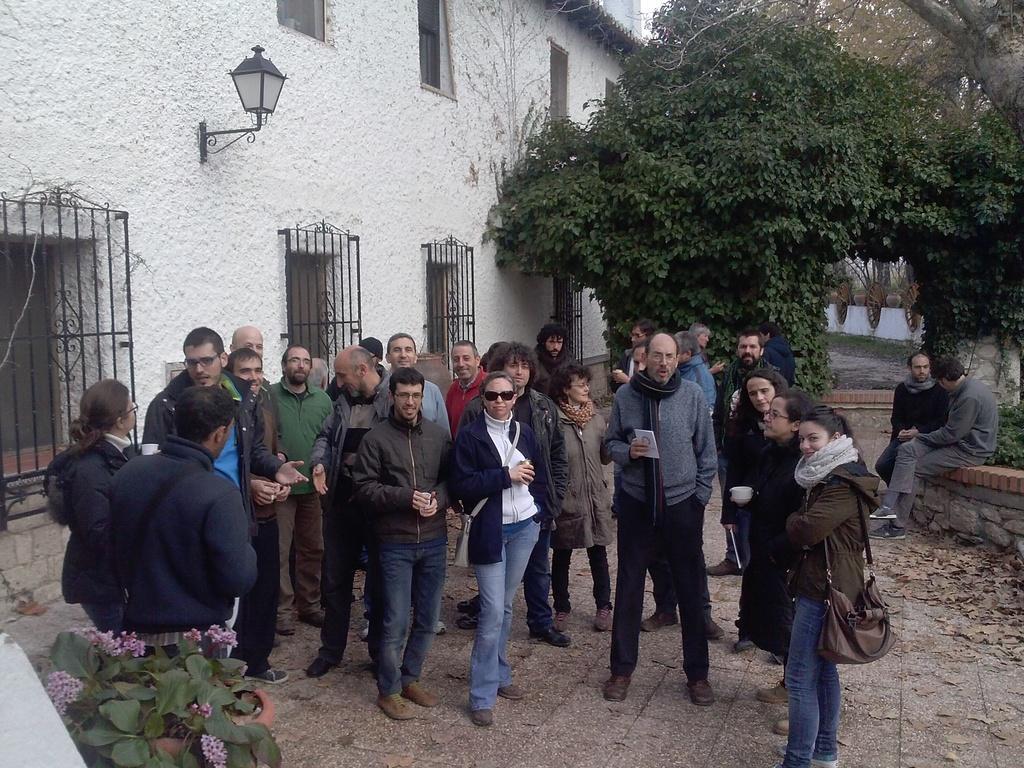In one or two sentences, can you explain what this image depicts? In the image in the center, we can see a few people are standing and holding some objects. In the background, we can see trees, buildings, windows, plants, flowers, grass and two persons are sitting. 